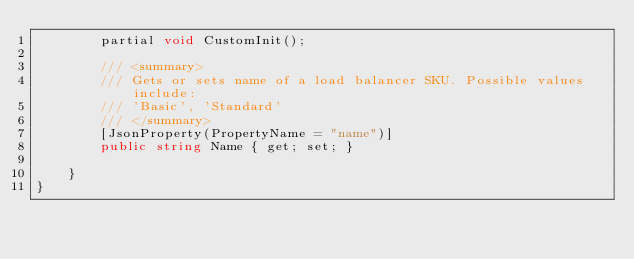<code> <loc_0><loc_0><loc_500><loc_500><_C#_>        partial void CustomInit();

        /// <summary>
        /// Gets or sets name of a load balancer SKU. Possible values include:
        /// 'Basic', 'Standard'
        /// </summary>
        [JsonProperty(PropertyName = "name")]
        public string Name { get; set; }

    }
}
</code> 